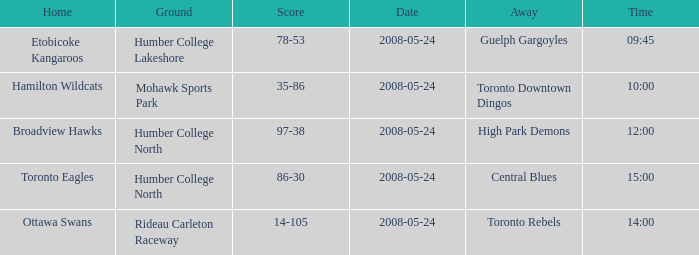Who was the home team of the game at the time of 15:00? Toronto Eagles. 